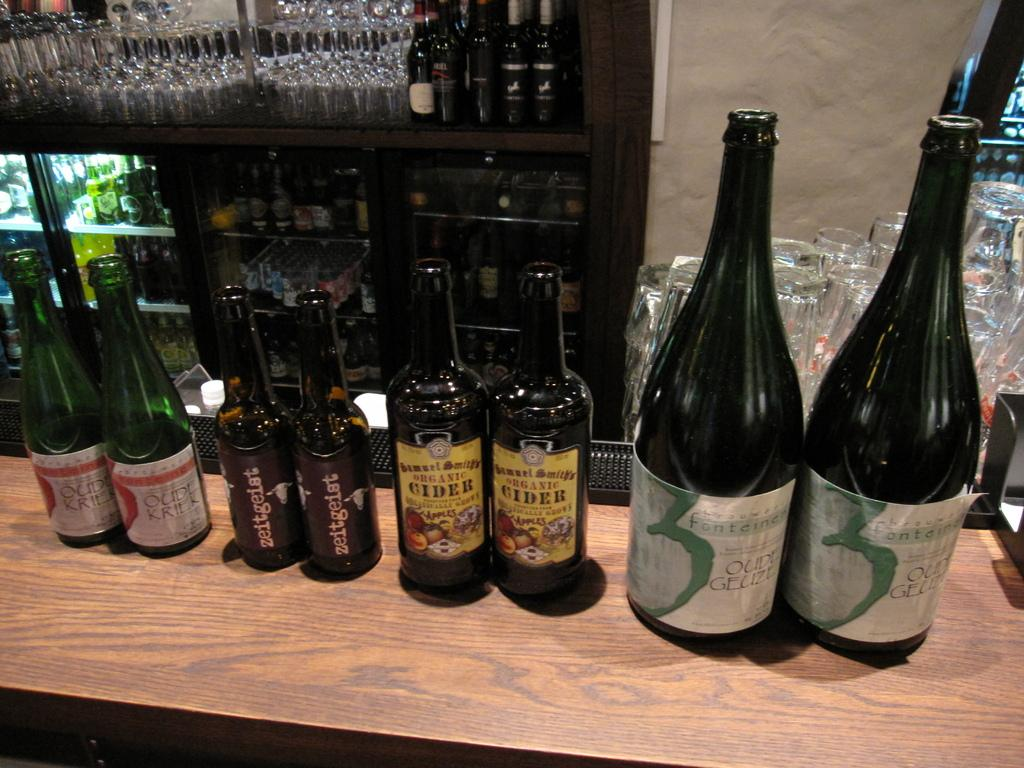<image>
Provide a brief description of the given image. 2 bottles each of oudl kriek, zeitgeist, organic cider, and oudl gelize 